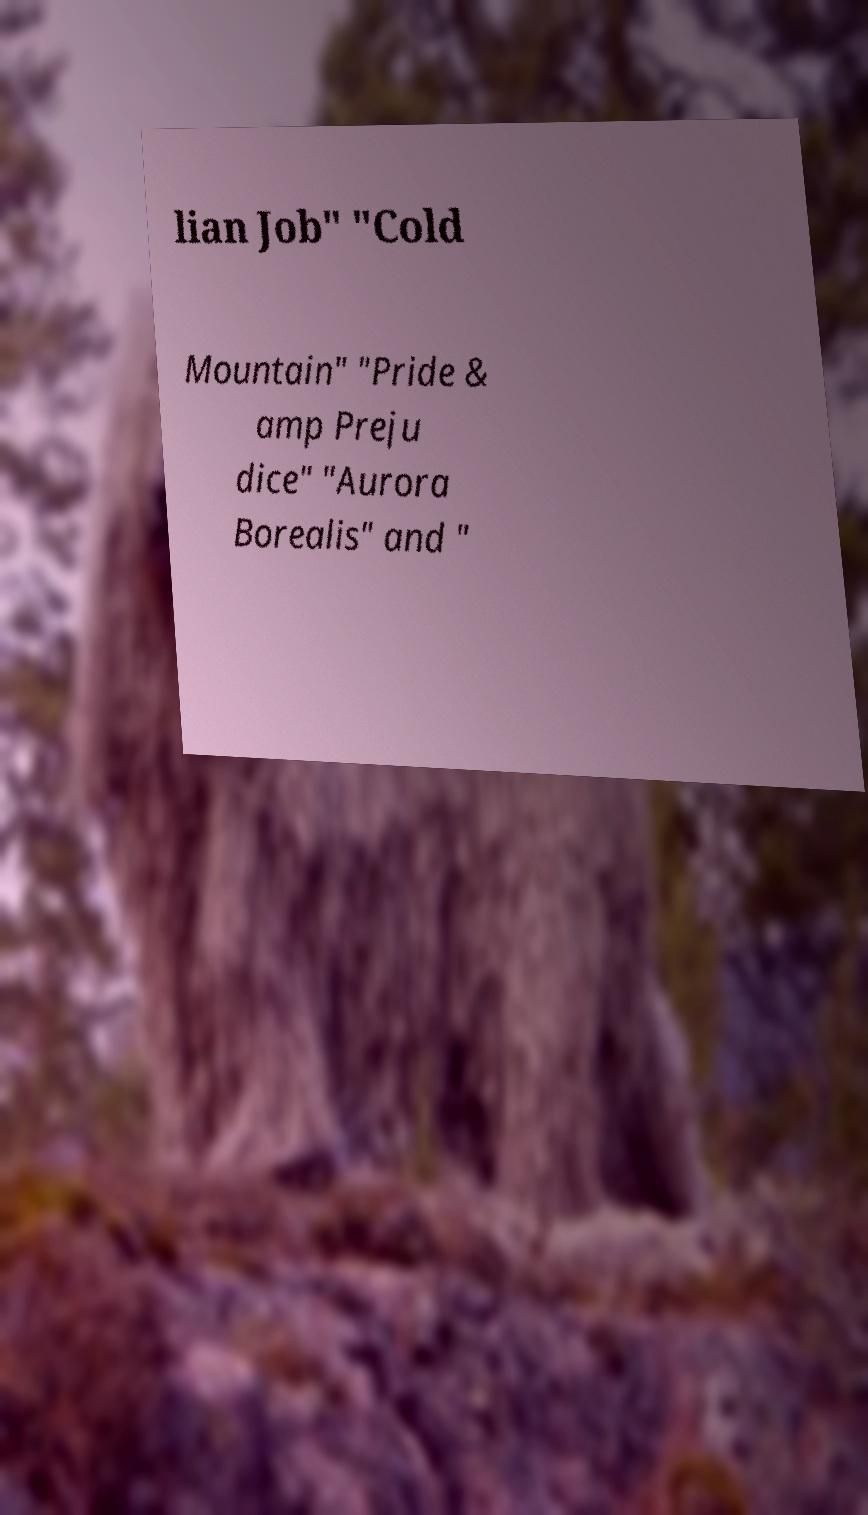For documentation purposes, I need the text within this image transcribed. Could you provide that? lian Job" "Cold Mountain" "Pride & amp Preju dice" "Aurora Borealis" and " 